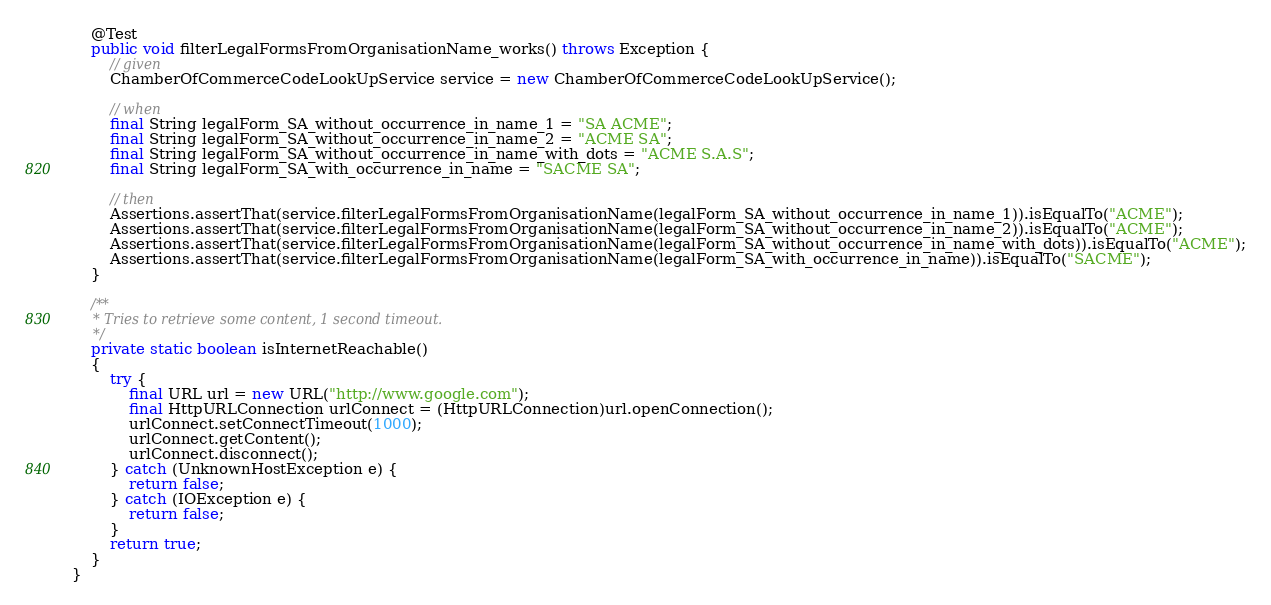Convert code to text. <code><loc_0><loc_0><loc_500><loc_500><_Java_>
    @Test
    public void filterLegalFormsFromOrganisationName_works() throws Exception {
        // given
        ChamberOfCommerceCodeLookUpService service = new ChamberOfCommerceCodeLookUpService();

        // when
        final String legalForm_SA_without_occurrence_in_name_1 = "SA ACME";
        final String legalForm_SA_without_occurrence_in_name_2 = "ACME SA";
        final String legalForm_SA_without_occurrence_in_name_with_dots = "ACME S.A.S";
        final String legalForm_SA_with_occurrence_in_name = "SACME SA";

        // then
        Assertions.assertThat(service.filterLegalFormsFromOrganisationName(legalForm_SA_without_occurrence_in_name_1)).isEqualTo("ACME");
        Assertions.assertThat(service.filterLegalFormsFromOrganisationName(legalForm_SA_without_occurrence_in_name_2)).isEqualTo("ACME");
        Assertions.assertThat(service.filterLegalFormsFromOrganisationName(legalForm_SA_without_occurrence_in_name_with_dots)).isEqualTo("ACME");
        Assertions.assertThat(service.filterLegalFormsFromOrganisationName(legalForm_SA_with_occurrence_in_name)).isEqualTo("SACME");
    }

    /**
     * Tries to retrieve some content, 1 second timeout.
     */
    private static boolean isInternetReachable()
    {
        try {
            final URL url = new URL("http://www.google.com");
            final HttpURLConnection urlConnect = (HttpURLConnection)url.openConnection();
            urlConnect.setConnectTimeout(1000);
            urlConnect.getContent();
            urlConnect.disconnect();
        } catch (UnknownHostException e) {
            return false;
        } catch (IOException e) {
            return false;
        }
        return true;
    }
}</code> 